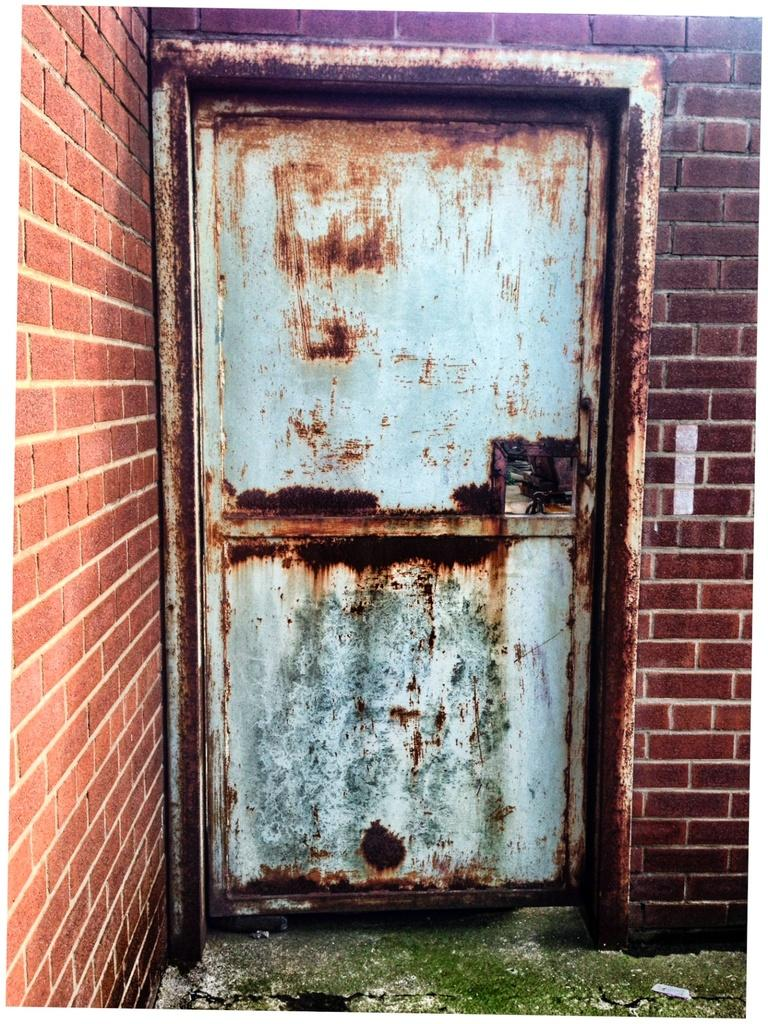What is the main subject in the middle of the image? There is an old iron door in the middle of the image. What can be seen in the background of the image? There is a wall in the background of the image. What flavor of cherry can be seen on the door in the image? There is no cherry or any flavor mentioned in the image; it features an old iron door and a wall in the background. 